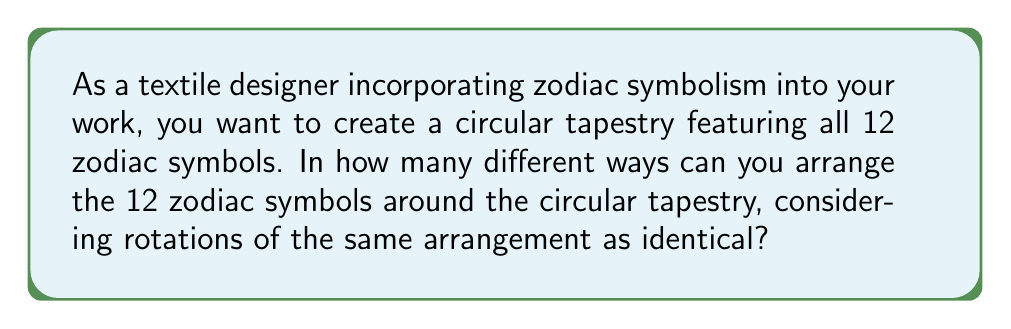Could you help me with this problem? To solve this problem, we need to consider the following steps:

1. First, we recognize that this is a circular arrangement problem. In circular arrangements, rotations of the same arrangement are considered identical.

2. The total number of ways to arrange 12 distinct objects in a line would be 12! (12 factorial). However, in a circular arrangement, we need to account for the rotational symmetry.

3. In a circular arrangement, there are 12 possible rotations of each unique arrangement that are considered identical. This is because we can rotate the circle 12 different ways, and each rotation would be considered the same arrangement.

4. To account for this, we divide the total number of linear arrangements by the number of rotations:

   $$ \text{Number of unique circular arrangements} = \frac{\text{Total linear arrangements}}{\text{Number of rotations}} = \frac{12!}{12} $$

5. Simplifying this expression:

   $$ \frac{12!}{12} = \frac{12 \cdot 11!}{12} = 11! $$

Therefore, the number of unique ways to arrange 12 zodiac symbols in a circular design is 11! (11 factorial).
Answer: $11! = 39,916,800$ 